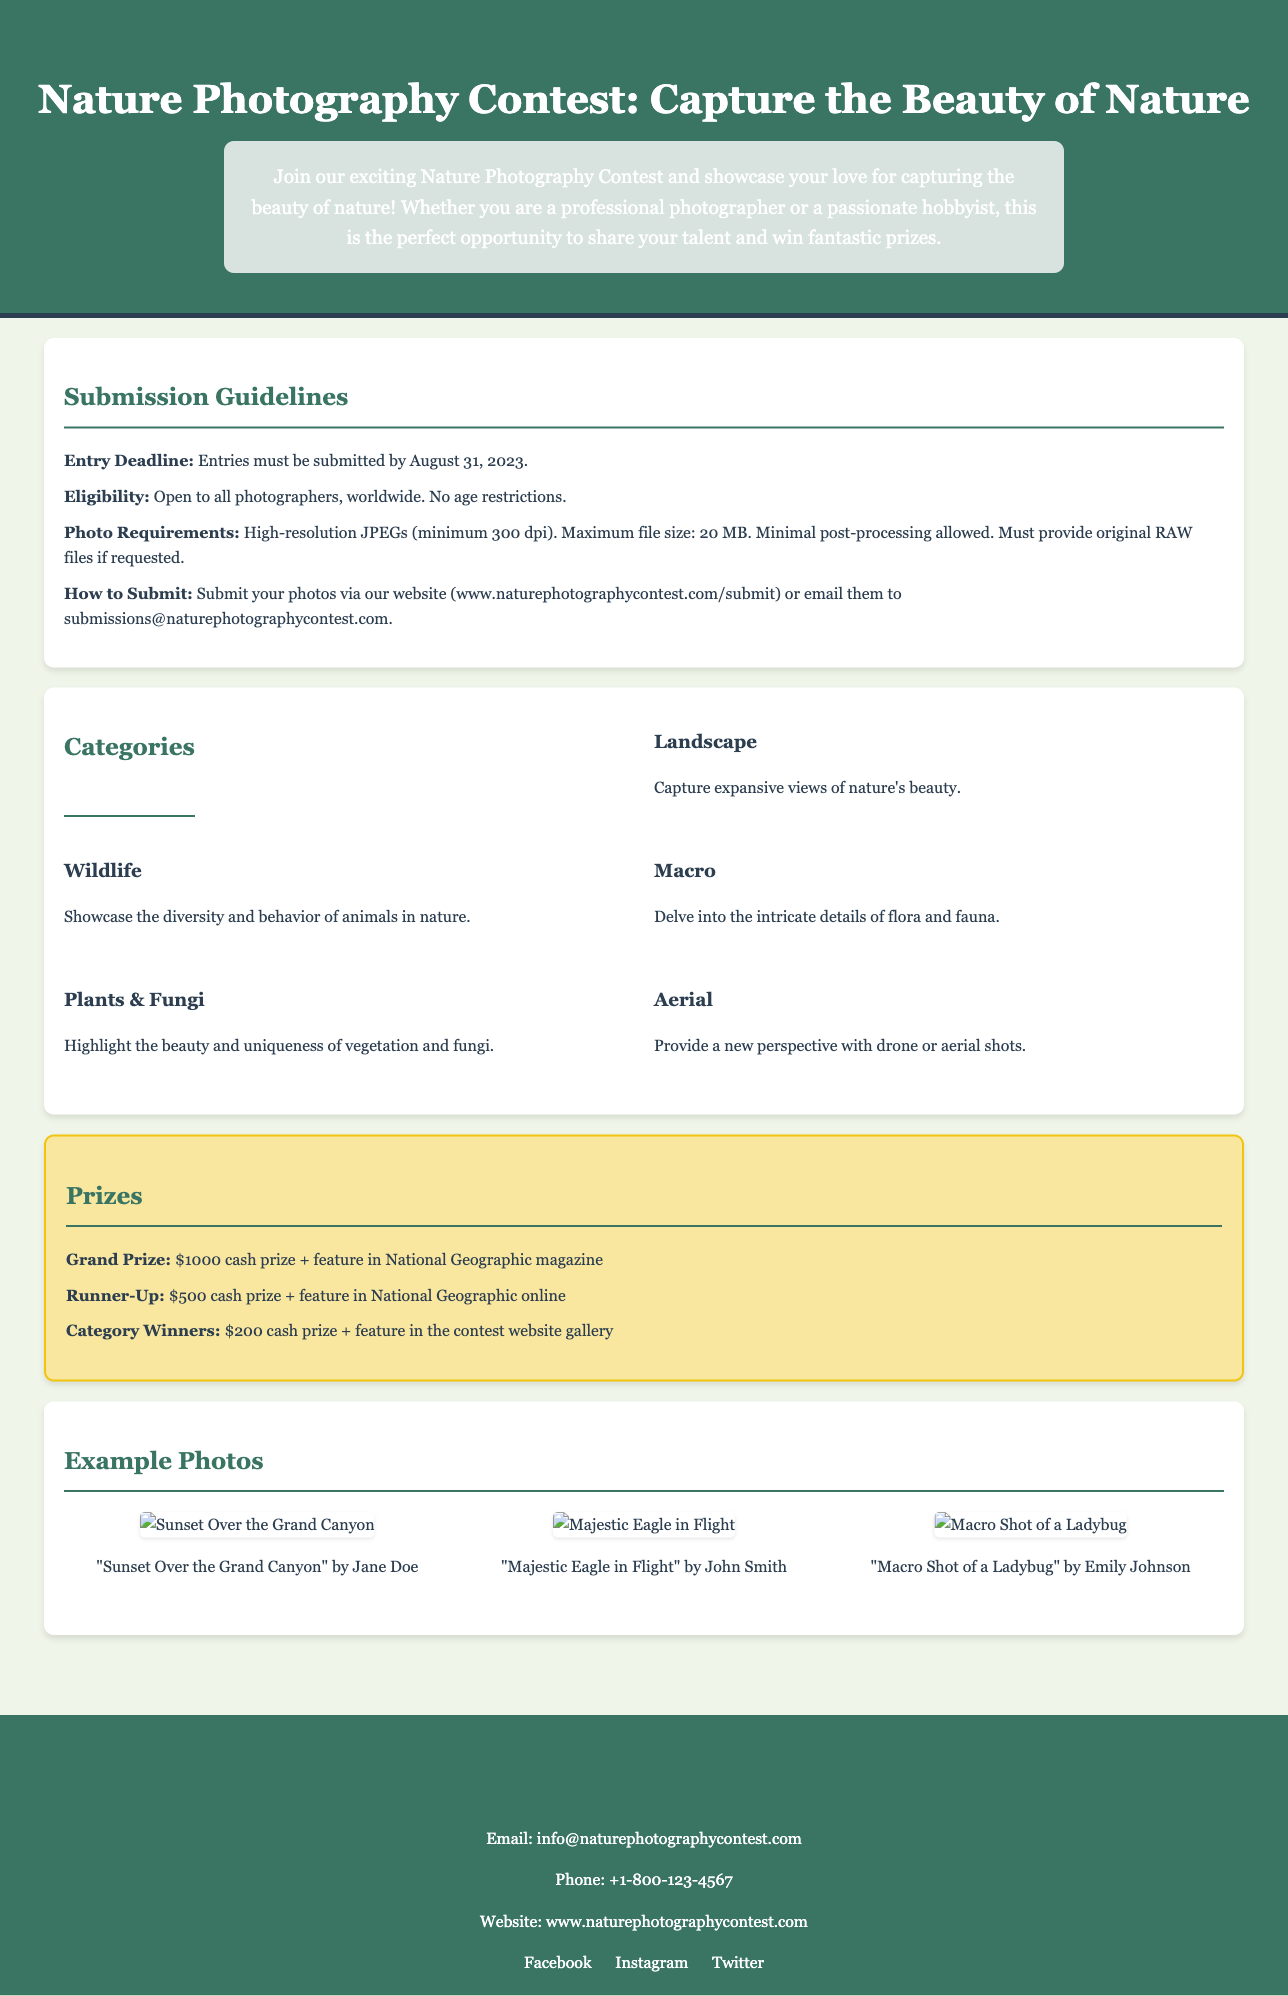What is the entry deadline? The entry deadline is clearly stated in the submission guidelines as August 31, 2023.
Answer: August 31, 2023 Who can participate in the contest? The eligibility section specifies that it is open to all photographers, worldwide, with no age restrictions.
Answer: All photographers, worldwide What is the maximum file size for photo submissions? The requirements detail that the maximum file size for submissions is 20 MB.
Answer: 20 MB What are the prizes for the Grand Prize winner? The prizes section lists that the Grand Prize includes a $1000 cash prize and a feature in National Geographic magazine.
Answer: $1000 cash prize + feature in National Geographic magazine How many categories are there in the contest? The categories section lists five distinct categories for the participants to choose from.
Answer: Five What type of photos are highlighted in the "Macro" category? The description under the "Macro" category indicates it focuses on the intricate details of flora and fauna.
Answer: Intricate details of flora and fauna Which photo features a bird in flight? The example photos specify that "Majestic Eagle in Flight" showcases a bird in flight.
Answer: Majestic Eagle in Flight What is the contact email provided for inquiries? The contact information section states the provided email for inquiries is info@naturephotographycontest.com.
Answer: info@naturephotographycontest.com Which social media platforms are mentioned? The footer lists three social media platforms where participants can follow the contest: Facebook, Instagram, and Twitter.
Answer: Facebook, Instagram, Twitter 